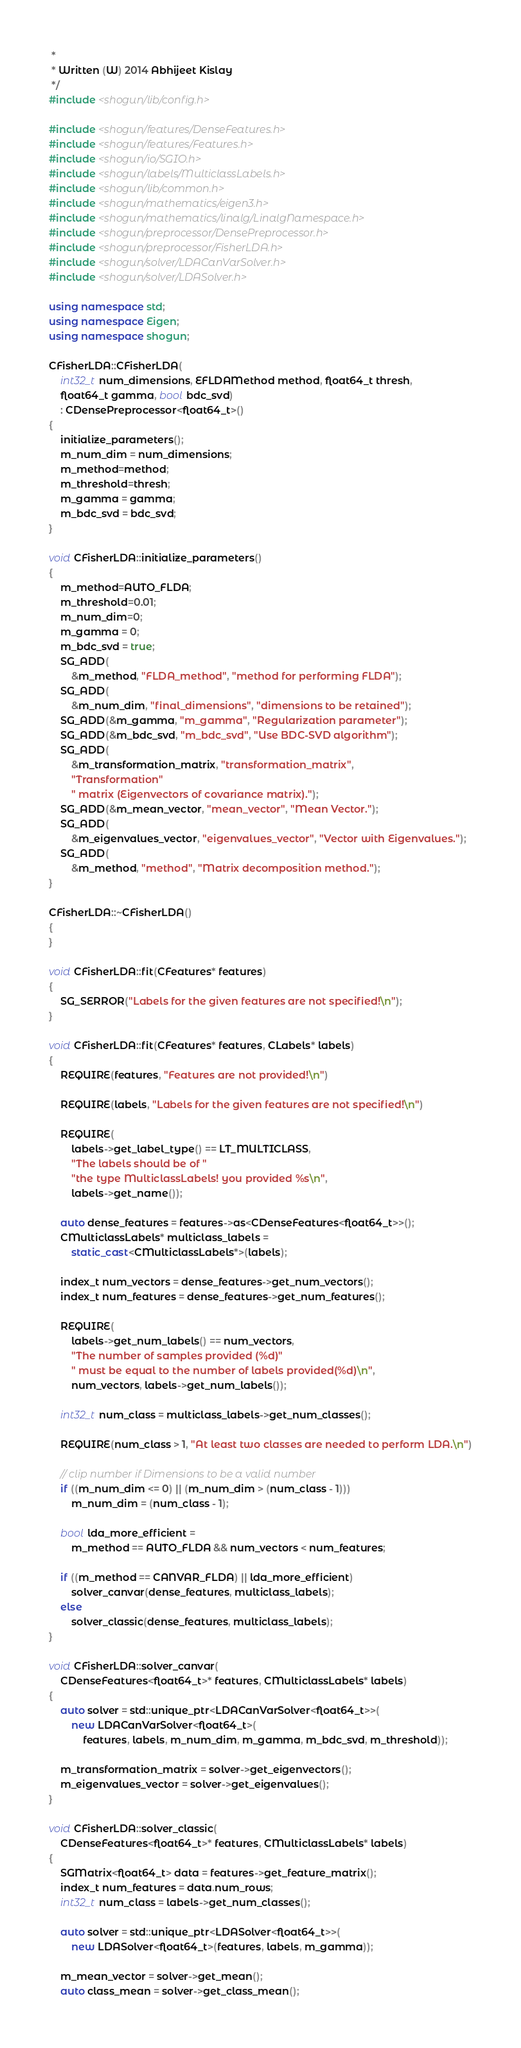Convert code to text. <code><loc_0><loc_0><loc_500><loc_500><_C++_> *
 * Written (W) 2014 Abhijeet Kislay
 */
#include <shogun/lib/config.h>

#include <shogun/features/DenseFeatures.h>
#include <shogun/features/Features.h>
#include <shogun/io/SGIO.h>
#include <shogun/labels/MulticlassLabels.h>
#include <shogun/lib/common.h>
#include <shogun/mathematics/eigen3.h>
#include <shogun/mathematics/linalg/LinalgNamespace.h>
#include <shogun/preprocessor/DensePreprocessor.h>
#include <shogun/preprocessor/FisherLDA.h>
#include <shogun/solver/LDACanVarSolver.h>
#include <shogun/solver/LDASolver.h>

using namespace std;
using namespace Eigen;
using namespace shogun;

CFisherLDA::CFisherLDA(
    int32_t num_dimensions, EFLDAMethod method, float64_t thresh,
    float64_t gamma, bool bdc_svd)
    : CDensePreprocessor<float64_t>()
{
	initialize_parameters();
	m_num_dim = num_dimensions;
	m_method=method;
	m_threshold=thresh;
	m_gamma = gamma;
	m_bdc_svd = bdc_svd;
}

void CFisherLDA::initialize_parameters()
{
	m_method=AUTO_FLDA;
	m_threshold=0.01;
	m_num_dim=0;
	m_gamma = 0;
	m_bdc_svd = true;
	SG_ADD(
	    &m_method, "FLDA_method", "method for performing FLDA");
	SG_ADD(
	    &m_num_dim, "final_dimensions", "dimensions to be retained");
	SG_ADD(&m_gamma, "m_gamma", "Regularization parameter");
	SG_ADD(&m_bdc_svd, "m_bdc_svd", "Use BDC-SVD algorithm");
	SG_ADD(
	    &m_transformation_matrix, "transformation_matrix",
	    "Transformation"
	    " matrix (Eigenvectors of covariance matrix).");
	SG_ADD(&m_mean_vector, "mean_vector", "Mean Vector.");
	SG_ADD(
	    &m_eigenvalues_vector, "eigenvalues_vector", "Vector with Eigenvalues.");
	SG_ADD(
	    &m_method, "method", "Matrix decomposition method.");
}

CFisherLDA::~CFisherLDA()
{
}

void CFisherLDA::fit(CFeatures* features)
{
	SG_SERROR("Labels for the given features are not specified!\n");
}

void CFisherLDA::fit(CFeatures* features, CLabels* labels)
{
	REQUIRE(features, "Features are not provided!\n")

	REQUIRE(labels, "Labels for the given features are not specified!\n")

	REQUIRE(
	    labels->get_label_type() == LT_MULTICLASS,
	    "The labels should be of "
	    "the type MulticlassLabels! you provided %s\n",
	    labels->get_name());

	auto dense_features = features->as<CDenseFeatures<float64_t>>();
	CMulticlassLabels* multiclass_labels =
	    static_cast<CMulticlassLabels*>(labels);

	index_t num_vectors = dense_features->get_num_vectors();
	index_t num_features = dense_features->get_num_features();

	REQUIRE(
	    labels->get_num_labels() == num_vectors,
	    "The number of samples provided (%d)"
	    " must be equal to the number of labels provided(%d)\n",
	    num_vectors, labels->get_num_labels());

	int32_t num_class = multiclass_labels->get_num_classes();

	REQUIRE(num_class > 1, "At least two classes are needed to perform LDA.\n")

	// clip number if Dimensions to be a valid number
	if ((m_num_dim <= 0) || (m_num_dim > (num_class - 1)))
		m_num_dim = (num_class - 1);

	bool lda_more_efficient =
	    m_method == AUTO_FLDA && num_vectors < num_features;

	if ((m_method == CANVAR_FLDA) || lda_more_efficient)
		solver_canvar(dense_features, multiclass_labels);
	else
		solver_classic(dense_features, multiclass_labels);
}

void CFisherLDA::solver_canvar(
    CDenseFeatures<float64_t>* features, CMulticlassLabels* labels)
{
	auto solver = std::unique_ptr<LDACanVarSolver<float64_t>>(
	    new LDACanVarSolver<float64_t>(
	        features, labels, m_num_dim, m_gamma, m_bdc_svd, m_threshold));

	m_transformation_matrix = solver->get_eigenvectors();
	m_eigenvalues_vector = solver->get_eigenvalues();
}

void CFisherLDA::solver_classic(
    CDenseFeatures<float64_t>* features, CMulticlassLabels* labels)
{
	SGMatrix<float64_t> data = features->get_feature_matrix();
	index_t num_features = data.num_rows;
	int32_t num_class = labels->get_num_classes();

	auto solver = std::unique_ptr<LDASolver<float64_t>>(
	    new LDASolver<float64_t>(features, labels, m_gamma));

	m_mean_vector = solver->get_mean();
	auto class_mean = solver->get_class_mean();</code> 